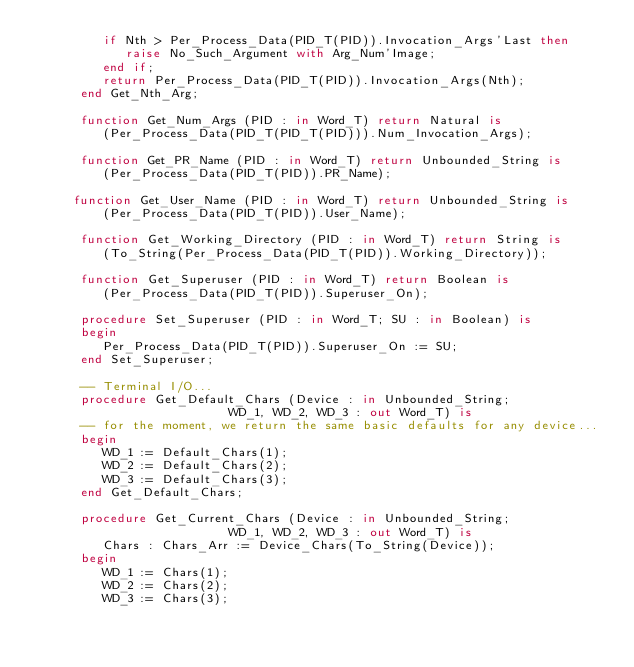Convert code to text. <code><loc_0><loc_0><loc_500><loc_500><_Ada_>         if Nth > Per_Process_Data(PID_T(PID)).Invocation_Args'Last then
            raise No_Such_Argument with Arg_Num'Image;
         end if;
         return Per_Process_Data(PID_T(PID)).Invocation_Args(Nth);
      end Get_Nth_Arg;

      function Get_Num_Args (PID : in Word_T) return Natural is
         (Per_Process_Data(PID_T(PID_T(PID))).Num_Invocation_Args);

      function Get_PR_Name (PID : in Word_T) return Unbounded_String is
         (Per_Process_Data(PID_T(PID)).PR_Name);

	   function Get_User_Name (PID : in Word_T) return Unbounded_String is
         (Per_Process_Data(PID_T(PID)).User_Name);

      function Get_Working_Directory (PID : in Word_T) return String is 
         (To_String(Per_Process_Data(PID_T(PID)).Working_Directory));

      function Get_Superuser (PID : in Word_T) return Boolean is
         (Per_Process_Data(PID_T(PID)).Superuser_On);

      procedure Set_Superuser (PID : in Word_T; SU : in Boolean) is
      begin
         Per_Process_Data(PID_T(PID)).Superuser_On := SU;
      end Set_Superuser;

      -- Terminal I/O...
      procedure Get_Default_Chars (Device : in Unbounded_String;
									        WD_1, WD_2, WD_3 : out Word_T) is
      -- for the moment, we return the same basic defaults for any device...
      begin
         WD_1 := Default_Chars(1);
         WD_2 := Default_Chars(2);
         WD_3 := Default_Chars(3);
      end Get_Default_Chars;

      procedure Get_Current_Chars (Device : in Unbounded_String;
									        WD_1, WD_2, WD_3 : out Word_T) is
         Chars : Chars_Arr := Device_Chars(To_String(Device));
      begin
         WD_1 := Chars(1);
         WD_2 := Chars(2);
         WD_3 := Chars(3);</code> 